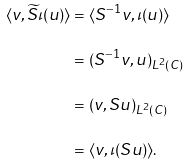Convert formula to latex. <formula><loc_0><loc_0><loc_500><loc_500>\langle v , \widetilde { S } \iota ( u ) \rangle & = \langle S ^ { - 1 } v , \iota ( u ) \rangle \\ & = ( S ^ { - 1 } v , u ) _ { L ^ { 2 } ( C ) } \\ & = ( v , S u ) _ { L ^ { 2 } ( C ) } \\ & = \langle v , \iota ( S u ) \rangle .</formula> 